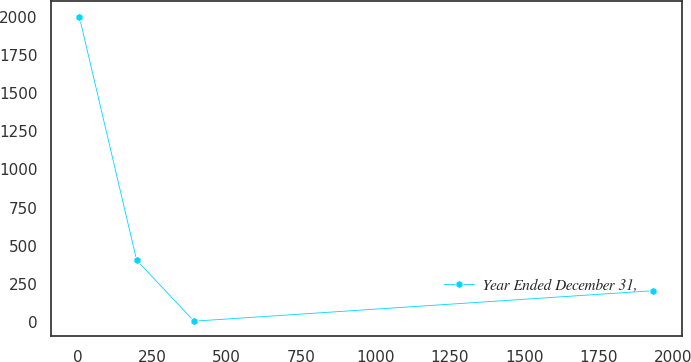Convert chart to OTSL. <chart><loc_0><loc_0><loc_500><loc_500><line_chart><ecel><fcel>Year Ended December 31,<nl><fcel>4.83<fcel>2001.65<nl><fcel>197.51<fcel>404.2<nl><fcel>390.19<fcel>4.84<nl><fcel>1931.6<fcel>204.52<nl></chart> 